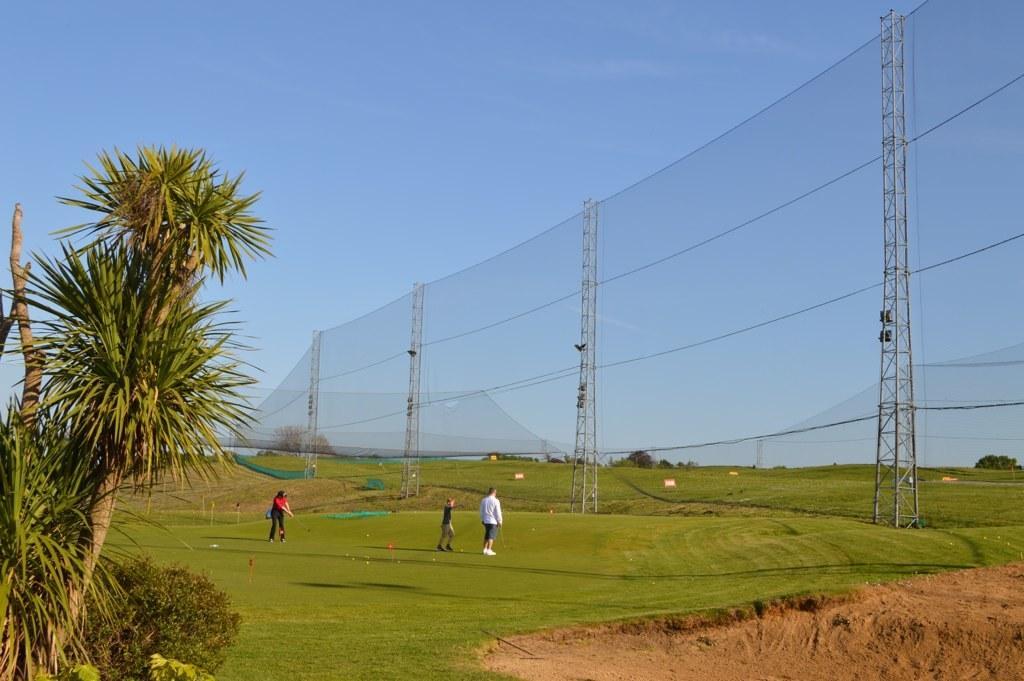In one or two sentences, can you explain what this image depicts? Here 3 persons are playing the golf, on the left side there are trees. On the right side it is a net, at the top it is the sky. 